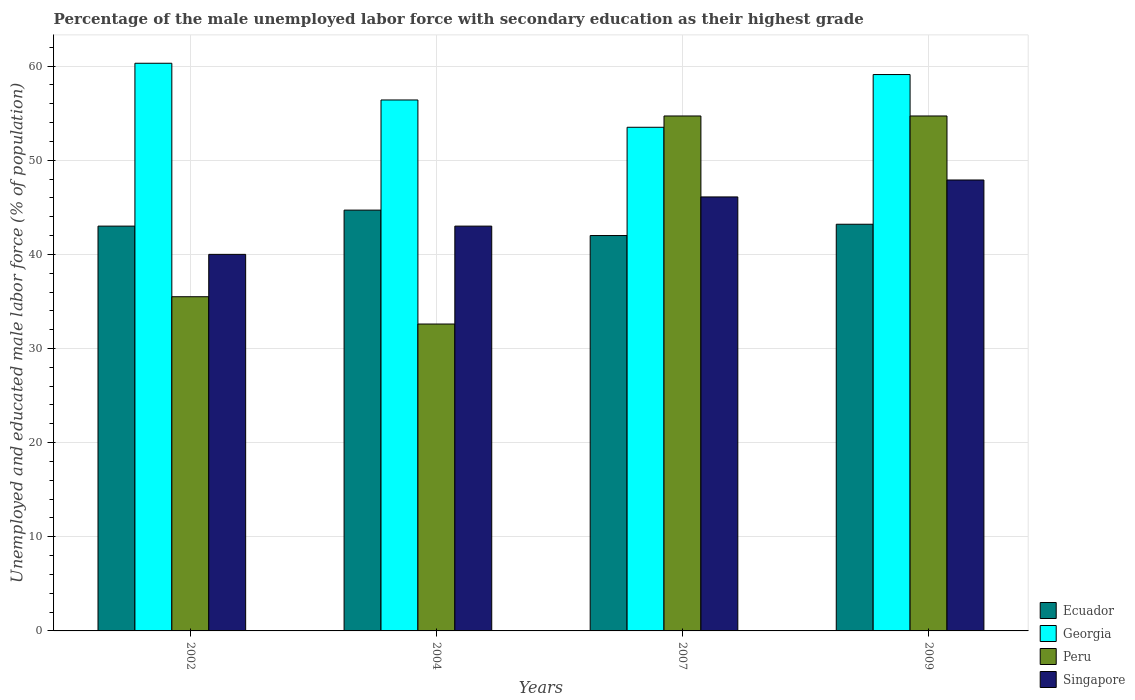How many different coloured bars are there?
Provide a short and direct response. 4. Are the number of bars per tick equal to the number of legend labels?
Make the answer very short. Yes. What is the label of the 2nd group of bars from the left?
Make the answer very short. 2004. What is the percentage of the unemployed male labor force with secondary education in Ecuador in 2004?
Your response must be concise. 44.7. Across all years, what is the maximum percentage of the unemployed male labor force with secondary education in Georgia?
Offer a terse response. 60.3. Across all years, what is the minimum percentage of the unemployed male labor force with secondary education in Peru?
Your answer should be compact. 32.6. In which year was the percentage of the unemployed male labor force with secondary education in Singapore maximum?
Offer a very short reply. 2009. What is the total percentage of the unemployed male labor force with secondary education in Peru in the graph?
Ensure brevity in your answer.  177.5. What is the difference between the percentage of the unemployed male labor force with secondary education in Georgia in 2002 and that in 2007?
Your response must be concise. 6.8. What is the difference between the percentage of the unemployed male labor force with secondary education in Georgia in 2002 and the percentage of the unemployed male labor force with secondary education in Peru in 2004?
Keep it short and to the point. 27.7. What is the average percentage of the unemployed male labor force with secondary education in Ecuador per year?
Provide a short and direct response. 43.23. In the year 2004, what is the difference between the percentage of the unemployed male labor force with secondary education in Ecuador and percentage of the unemployed male labor force with secondary education in Peru?
Offer a very short reply. 12.1. In how many years, is the percentage of the unemployed male labor force with secondary education in Georgia greater than 42 %?
Your response must be concise. 4. What is the ratio of the percentage of the unemployed male labor force with secondary education in Georgia in 2004 to that in 2009?
Offer a terse response. 0.95. Is the percentage of the unemployed male labor force with secondary education in Peru in 2002 less than that in 2004?
Provide a succinct answer. No. What is the difference between the highest and the second highest percentage of the unemployed male labor force with secondary education in Ecuador?
Your answer should be very brief. 1.5. What is the difference between the highest and the lowest percentage of the unemployed male labor force with secondary education in Singapore?
Provide a short and direct response. 7.9. In how many years, is the percentage of the unemployed male labor force with secondary education in Georgia greater than the average percentage of the unemployed male labor force with secondary education in Georgia taken over all years?
Your answer should be very brief. 2. Is it the case that in every year, the sum of the percentage of the unemployed male labor force with secondary education in Peru and percentage of the unemployed male labor force with secondary education in Singapore is greater than the sum of percentage of the unemployed male labor force with secondary education in Georgia and percentage of the unemployed male labor force with secondary education in Ecuador?
Your answer should be very brief. No. What does the 4th bar from the left in 2004 represents?
Your response must be concise. Singapore. Are all the bars in the graph horizontal?
Make the answer very short. No. How many years are there in the graph?
Provide a succinct answer. 4. Are the values on the major ticks of Y-axis written in scientific E-notation?
Your answer should be very brief. No. Does the graph contain any zero values?
Keep it short and to the point. No. Does the graph contain grids?
Keep it short and to the point. Yes. How many legend labels are there?
Ensure brevity in your answer.  4. How are the legend labels stacked?
Offer a terse response. Vertical. What is the title of the graph?
Offer a very short reply. Percentage of the male unemployed labor force with secondary education as their highest grade. What is the label or title of the Y-axis?
Your response must be concise. Unemployed and educated male labor force (% of population). What is the Unemployed and educated male labor force (% of population) of Georgia in 2002?
Your answer should be compact. 60.3. What is the Unemployed and educated male labor force (% of population) in Peru in 2002?
Provide a short and direct response. 35.5. What is the Unemployed and educated male labor force (% of population) in Singapore in 2002?
Give a very brief answer. 40. What is the Unemployed and educated male labor force (% of population) in Ecuador in 2004?
Your response must be concise. 44.7. What is the Unemployed and educated male labor force (% of population) in Georgia in 2004?
Keep it short and to the point. 56.4. What is the Unemployed and educated male labor force (% of population) in Peru in 2004?
Provide a short and direct response. 32.6. What is the Unemployed and educated male labor force (% of population) in Singapore in 2004?
Make the answer very short. 43. What is the Unemployed and educated male labor force (% of population) in Ecuador in 2007?
Give a very brief answer. 42. What is the Unemployed and educated male labor force (% of population) of Georgia in 2007?
Provide a succinct answer. 53.5. What is the Unemployed and educated male labor force (% of population) of Peru in 2007?
Provide a short and direct response. 54.7. What is the Unemployed and educated male labor force (% of population) in Singapore in 2007?
Your response must be concise. 46.1. What is the Unemployed and educated male labor force (% of population) of Ecuador in 2009?
Provide a succinct answer. 43.2. What is the Unemployed and educated male labor force (% of population) in Georgia in 2009?
Provide a short and direct response. 59.1. What is the Unemployed and educated male labor force (% of population) in Peru in 2009?
Keep it short and to the point. 54.7. What is the Unemployed and educated male labor force (% of population) in Singapore in 2009?
Provide a succinct answer. 47.9. Across all years, what is the maximum Unemployed and educated male labor force (% of population) in Ecuador?
Make the answer very short. 44.7. Across all years, what is the maximum Unemployed and educated male labor force (% of population) in Georgia?
Keep it short and to the point. 60.3. Across all years, what is the maximum Unemployed and educated male labor force (% of population) of Peru?
Provide a succinct answer. 54.7. Across all years, what is the maximum Unemployed and educated male labor force (% of population) in Singapore?
Give a very brief answer. 47.9. Across all years, what is the minimum Unemployed and educated male labor force (% of population) in Georgia?
Provide a succinct answer. 53.5. Across all years, what is the minimum Unemployed and educated male labor force (% of population) of Peru?
Ensure brevity in your answer.  32.6. Across all years, what is the minimum Unemployed and educated male labor force (% of population) in Singapore?
Give a very brief answer. 40. What is the total Unemployed and educated male labor force (% of population) of Ecuador in the graph?
Ensure brevity in your answer.  172.9. What is the total Unemployed and educated male labor force (% of population) of Georgia in the graph?
Offer a very short reply. 229.3. What is the total Unemployed and educated male labor force (% of population) of Peru in the graph?
Keep it short and to the point. 177.5. What is the total Unemployed and educated male labor force (% of population) in Singapore in the graph?
Provide a succinct answer. 177. What is the difference between the Unemployed and educated male labor force (% of population) of Georgia in 2002 and that in 2004?
Offer a terse response. 3.9. What is the difference between the Unemployed and educated male labor force (% of population) of Peru in 2002 and that in 2004?
Your response must be concise. 2.9. What is the difference between the Unemployed and educated male labor force (% of population) of Singapore in 2002 and that in 2004?
Offer a very short reply. -3. What is the difference between the Unemployed and educated male labor force (% of population) of Ecuador in 2002 and that in 2007?
Your response must be concise. 1. What is the difference between the Unemployed and educated male labor force (% of population) in Georgia in 2002 and that in 2007?
Your answer should be compact. 6.8. What is the difference between the Unemployed and educated male labor force (% of population) in Peru in 2002 and that in 2007?
Offer a terse response. -19.2. What is the difference between the Unemployed and educated male labor force (% of population) in Singapore in 2002 and that in 2007?
Give a very brief answer. -6.1. What is the difference between the Unemployed and educated male labor force (% of population) of Peru in 2002 and that in 2009?
Give a very brief answer. -19.2. What is the difference between the Unemployed and educated male labor force (% of population) of Georgia in 2004 and that in 2007?
Your answer should be compact. 2.9. What is the difference between the Unemployed and educated male labor force (% of population) in Peru in 2004 and that in 2007?
Offer a very short reply. -22.1. What is the difference between the Unemployed and educated male labor force (% of population) in Ecuador in 2004 and that in 2009?
Ensure brevity in your answer.  1.5. What is the difference between the Unemployed and educated male labor force (% of population) of Peru in 2004 and that in 2009?
Give a very brief answer. -22.1. What is the difference between the Unemployed and educated male labor force (% of population) in Singapore in 2004 and that in 2009?
Offer a terse response. -4.9. What is the difference between the Unemployed and educated male labor force (% of population) of Ecuador in 2007 and that in 2009?
Provide a short and direct response. -1.2. What is the difference between the Unemployed and educated male labor force (% of population) of Singapore in 2007 and that in 2009?
Make the answer very short. -1.8. What is the difference between the Unemployed and educated male labor force (% of population) of Georgia in 2002 and the Unemployed and educated male labor force (% of population) of Peru in 2004?
Offer a terse response. 27.7. What is the difference between the Unemployed and educated male labor force (% of population) in Georgia in 2002 and the Unemployed and educated male labor force (% of population) in Singapore in 2004?
Give a very brief answer. 17.3. What is the difference between the Unemployed and educated male labor force (% of population) of Peru in 2002 and the Unemployed and educated male labor force (% of population) of Singapore in 2004?
Keep it short and to the point. -7.5. What is the difference between the Unemployed and educated male labor force (% of population) in Ecuador in 2002 and the Unemployed and educated male labor force (% of population) in Peru in 2007?
Make the answer very short. -11.7. What is the difference between the Unemployed and educated male labor force (% of population) of Georgia in 2002 and the Unemployed and educated male labor force (% of population) of Peru in 2007?
Your response must be concise. 5.6. What is the difference between the Unemployed and educated male labor force (% of population) in Ecuador in 2002 and the Unemployed and educated male labor force (% of population) in Georgia in 2009?
Your answer should be compact. -16.1. What is the difference between the Unemployed and educated male labor force (% of population) in Peru in 2002 and the Unemployed and educated male labor force (% of population) in Singapore in 2009?
Provide a succinct answer. -12.4. What is the difference between the Unemployed and educated male labor force (% of population) of Ecuador in 2004 and the Unemployed and educated male labor force (% of population) of Peru in 2007?
Offer a terse response. -10. What is the difference between the Unemployed and educated male labor force (% of population) in Ecuador in 2004 and the Unemployed and educated male labor force (% of population) in Singapore in 2007?
Offer a very short reply. -1.4. What is the difference between the Unemployed and educated male labor force (% of population) in Georgia in 2004 and the Unemployed and educated male labor force (% of population) in Singapore in 2007?
Ensure brevity in your answer.  10.3. What is the difference between the Unemployed and educated male labor force (% of population) of Ecuador in 2004 and the Unemployed and educated male labor force (% of population) of Georgia in 2009?
Your response must be concise. -14.4. What is the difference between the Unemployed and educated male labor force (% of population) of Ecuador in 2004 and the Unemployed and educated male labor force (% of population) of Peru in 2009?
Make the answer very short. -10. What is the difference between the Unemployed and educated male labor force (% of population) of Ecuador in 2004 and the Unemployed and educated male labor force (% of population) of Singapore in 2009?
Give a very brief answer. -3.2. What is the difference between the Unemployed and educated male labor force (% of population) of Peru in 2004 and the Unemployed and educated male labor force (% of population) of Singapore in 2009?
Your answer should be compact. -15.3. What is the difference between the Unemployed and educated male labor force (% of population) of Ecuador in 2007 and the Unemployed and educated male labor force (% of population) of Georgia in 2009?
Offer a very short reply. -17.1. What is the difference between the Unemployed and educated male labor force (% of population) of Ecuador in 2007 and the Unemployed and educated male labor force (% of population) of Peru in 2009?
Offer a terse response. -12.7. What is the difference between the Unemployed and educated male labor force (% of population) in Ecuador in 2007 and the Unemployed and educated male labor force (% of population) in Singapore in 2009?
Give a very brief answer. -5.9. What is the difference between the Unemployed and educated male labor force (% of population) of Georgia in 2007 and the Unemployed and educated male labor force (% of population) of Peru in 2009?
Your response must be concise. -1.2. What is the average Unemployed and educated male labor force (% of population) in Ecuador per year?
Give a very brief answer. 43.23. What is the average Unemployed and educated male labor force (% of population) in Georgia per year?
Your response must be concise. 57.33. What is the average Unemployed and educated male labor force (% of population) of Peru per year?
Give a very brief answer. 44.38. What is the average Unemployed and educated male labor force (% of population) of Singapore per year?
Provide a succinct answer. 44.25. In the year 2002, what is the difference between the Unemployed and educated male labor force (% of population) of Ecuador and Unemployed and educated male labor force (% of population) of Georgia?
Keep it short and to the point. -17.3. In the year 2002, what is the difference between the Unemployed and educated male labor force (% of population) in Ecuador and Unemployed and educated male labor force (% of population) in Peru?
Make the answer very short. 7.5. In the year 2002, what is the difference between the Unemployed and educated male labor force (% of population) in Georgia and Unemployed and educated male labor force (% of population) in Peru?
Your answer should be compact. 24.8. In the year 2002, what is the difference between the Unemployed and educated male labor force (% of population) in Georgia and Unemployed and educated male labor force (% of population) in Singapore?
Offer a terse response. 20.3. In the year 2002, what is the difference between the Unemployed and educated male labor force (% of population) in Peru and Unemployed and educated male labor force (% of population) in Singapore?
Provide a short and direct response. -4.5. In the year 2004, what is the difference between the Unemployed and educated male labor force (% of population) in Ecuador and Unemployed and educated male labor force (% of population) in Georgia?
Your response must be concise. -11.7. In the year 2004, what is the difference between the Unemployed and educated male labor force (% of population) of Ecuador and Unemployed and educated male labor force (% of population) of Singapore?
Your response must be concise. 1.7. In the year 2004, what is the difference between the Unemployed and educated male labor force (% of population) of Georgia and Unemployed and educated male labor force (% of population) of Peru?
Ensure brevity in your answer.  23.8. In the year 2004, what is the difference between the Unemployed and educated male labor force (% of population) in Georgia and Unemployed and educated male labor force (% of population) in Singapore?
Offer a very short reply. 13.4. In the year 2004, what is the difference between the Unemployed and educated male labor force (% of population) in Peru and Unemployed and educated male labor force (% of population) in Singapore?
Provide a succinct answer. -10.4. In the year 2007, what is the difference between the Unemployed and educated male labor force (% of population) of Ecuador and Unemployed and educated male labor force (% of population) of Peru?
Your response must be concise. -12.7. In the year 2007, what is the difference between the Unemployed and educated male labor force (% of population) of Peru and Unemployed and educated male labor force (% of population) of Singapore?
Provide a short and direct response. 8.6. In the year 2009, what is the difference between the Unemployed and educated male labor force (% of population) in Ecuador and Unemployed and educated male labor force (% of population) in Georgia?
Offer a terse response. -15.9. In the year 2009, what is the difference between the Unemployed and educated male labor force (% of population) of Georgia and Unemployed and educated male labor force (% of population) of Peru?
Make the answer very short. 4.4. In the year 2009, what is the difference between the Unemployed and educated male labor force (% of population) of Georgia and Unemployed and educated male labor force (% of population) of Singapore?
Your response must be concise. 11.2. In the year 2009, what is the difference between the Unemployed and educated male labor force (% of population) of Peru and Unemployed and educated male labor force (% of population) of Singapore?
Offer a terse response. 6.8. What is the ratio of the Unemployed and educated male labor force (% of population) of Ecuador in 2002 to that in 2004?
Ensure brevity in your answer.  0.96. What is the ratio of the Unemployed and educated male labor force (% of population) in Georgia in 2002 to that in 2004?
Your response must be concise. 1.07. What is the ratio of the Unemployed and educated male labor force (% of population) in Peru in 2002 to that in 2004?
Provide a short and direct response. 1.09. What is the ratio of the Unemployed and educated male labor force (% of population) of Singapore in 2002 to that in 2004?
Your answer should be compact. 0.93. What is the ratio of the Unemployed and educated male labor force (% of population) of Ecuador in 2002 to that in 2007?
Your response must be concise. 1.02. What is the ratio of the Unemployed and educated male labor force (% of population) in Georgia in 2002 to that in 2007?
Your response must be concise. 1.13. What is the ratio of the Unemployed and educated male labor force (% of population) in Peru in 2002 to that in 2007?
Offer a terse response. 0.65. What is the ratio of the Unemployed and educated male labor force (% of population) in Singapore in 2002 to that in 2007?
Your answer should be very brief. 0.87. What is the ratio of the Unemployed and educated male labor force (% of population) of Ecuador in 2002 to that in 2009?
Make the answer very short. 1. What is the ratio of the Unemployed and educated male labor force (% of population) of Georgia in 2002 to that in 2009?
Your answer should be compact. 1.02. What is the ratio of the Unemployed and educated male labor force (% of population) of Peru in 2002 to that in 2009?
Give a very brief answer. 0.65. What is the ratio of the Unemployed and educated male labor force (% of population) of Singapore in 2002 to that in 2009?
Provide a short and direct response. 0.84. What is the ratio of the Unemployed and educated male labor force (% of population) of Ecuador in 2004 to that in 2007?
Offer a very short reply. 1.06. What is the ratio of the Unemployed and educated male labor force (% of population) in Georgia in 2004 to that in 2007?
Give a very brief answer. 1.05. What is the ratio of the Unemployed and educated male labor force (% of population) in Peru in 2004 to that in 2007?
Your response must be concise. 0.6. What is the ratio of the Unemployed and educated male labor force (% of population) in Singapore in 2004 to that in 2007?
Your response must be concise. 0.93. What is the ratio of the Unemployed and educated male labor force (% of population) in Ecuador in 2004 to that in 2009?
Ensure brevity in your answer.  1.03. What is the ratio of the Unemployed and educated male labor force (% of population) of Georgia in 2004 to that in 2009?
Keep it short and to the point. 0.95. What is the ratio of the Unemployed and educated male labor force (% of population) in Peru in 2004 to that in 2009?
Your answer should be compact. 0.6. What is the ratio of the Unemployed and educated male labor force (% of population) in Singapore in 2004 to that in 2009?
Ensure brevity in your answer.  0.9. What is the ratio of the Unemployed and educated male labor force (% of population) of Ecuador in 2007 to that in 2009?
Offer a very short reply. 0.97. What is the ratio of the Unemployed and educated male labor force (% of population) in Georgia in 2007 to that in 2009?
Offer a very short reply. 0.91. What is the ratio of the Unemployed and educated male labor force (% of population) of Peru in 2007 to that in 2009?
Your answer should be compact. 1. What is the ratio of the Unemployed and educated male labor force (% of population) in Singapore in 2007 to that in 2009?
Your response must be concise. 0.96. What is the difference between the highest and the second highest Unemployed and educated male labor force (% of population) of Georgia?
Provide a short and direct response. 1.2. What is the difference between the highest and the lowest Unemployed and educated male labor force (% of population) in Georgia?
Your answer should be compact. 6.8. What is the difference between the highest and the lowest Unemployed and educated male labor force (% of population) of Peru?
Your response must be concise. 22.1. What is the difference between the highest and the lowest Unemployed and educated male labor force (% of population) in Singapore?
Ensure brevity in your answer.  7.9. 